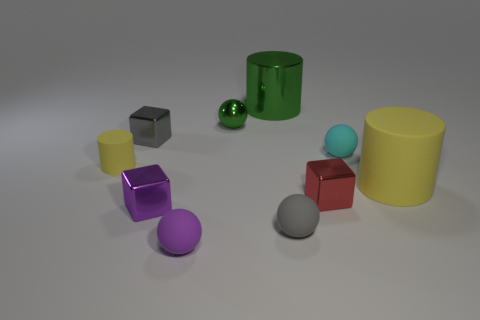Subtract all cylinders. How many objects are left? 7 Subtract 0 brown blocks. How many objects are left? 10 Subtract all small metallic cubes. Subtract all yellow matte things. How many objects are left? 5 Add 5 small red blocks. How many small red blocks are left? 6 Add 7 large blue matte balls. How many large blue matte balls exist? 7 